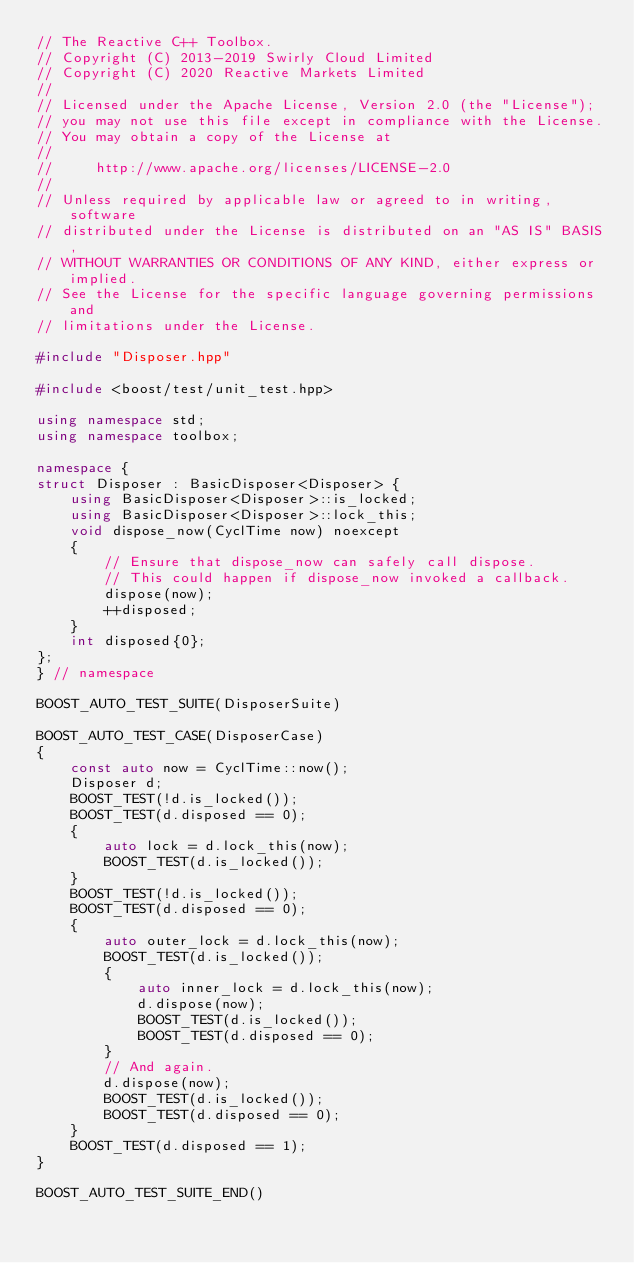<code> <loc_0><loc_0><loc_500><loc_500><_C++_>// The Reactive C++ Toolbox.
// Copyright (C) 2013-2019 Swirly Cloud Limited
// Copyright (C) 2020 Reactive Markets Limited
//
// Licensed under the Apache License, Version 2.0 (the "License");
// you may not use this file except in compliance with the License.
// You may obtain a copy of the License at
//
//     http://www.apache.org/licenses/LICENSE-2.0
//
// Unless required by applicable law or agreed to in writing, software
// distributed under the License is distributed on an "AS IS" BASIS,
// WITHOUT WARRANTIES OR CONDITIONS OF ANY KIND, either express or implied.
// See the License for the specific language governing permissions and
// limitations under the License.

#include "Disposer.hpp"

#include <boost/test/unit_test.hpp>

using namespace std;
using namespace toolbox;

namespace {
struct Disposer : BasicDisposer<Disposer> {
    using BasicDisposer<Disposer>::is_locked;
    using BasicDisposer<Disposer>::lock_this;
    void dispose_now(CyclTime now) noexcept
    {
        // Ensure that dispose_now can safely call dispose.
        // This could happen if dispose_now invoked a callback.
        dispose(now);
        ++disposed;
    }
    int disposed{0};
};
} // namespace

BOOST_AUTO_TEST_SUITE(DisposerSuite)

BOOST_AUTO_TEST_CASE(DisposerCase)
{
    const auto now = CyclTime::now();
    Disposer d;
    BOOST_TEST(!d.is_locked());
    BOOST_TEST(d.disposed == 0);
    {
        auto lock = d.lock_this(now);
        BOOST_TEST(d.is_locked());
    }
    BOOST_TEST(!d.is_locked());
    BOOST_TEST(d.disposed == 0);
    {
        auto outer_lock = d.lock_this(now);
        BOOST_TEST(d.is_locked());
        {
            auto inner_lock = d.lock_this(now);
            d.dispose(now);
            BOOST_TEST(d.is_locked());
            BOOST_TEST(d.disposed == 0);
        }
        // And again.
        d.dispose(now);
        BOOST_TEST(d.is_locked());
        BOOST_TEST(d.disposed == 0);
    }
    BOOST_TEST(d.disposed == 1);
}

BOOST_AUTO_TEST_SUITE_END()
</code> 